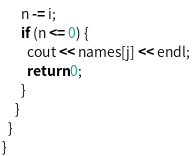Convert code to text. <code><loc_0><loc_0><loc_500><loc_500><_C++_>      n -= i;
      if (n <= 0) {
        cout << names[j] << endl;
        return 0;
      }
    }
  }
}
</code> 